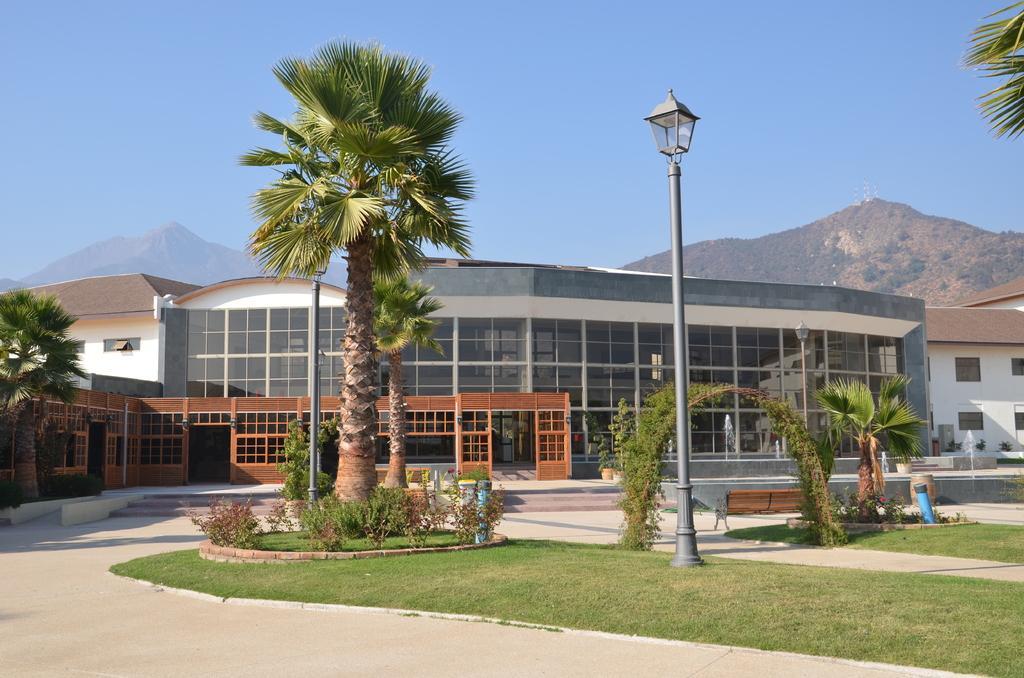Can you describe this image briefly? In this image we can see the buildings, trees and also the hills. We can also see a light pole, fountain, bench and also some plants and grass. There is an arch with the grass. At the top there is sky and at the bottom we can see the path. 